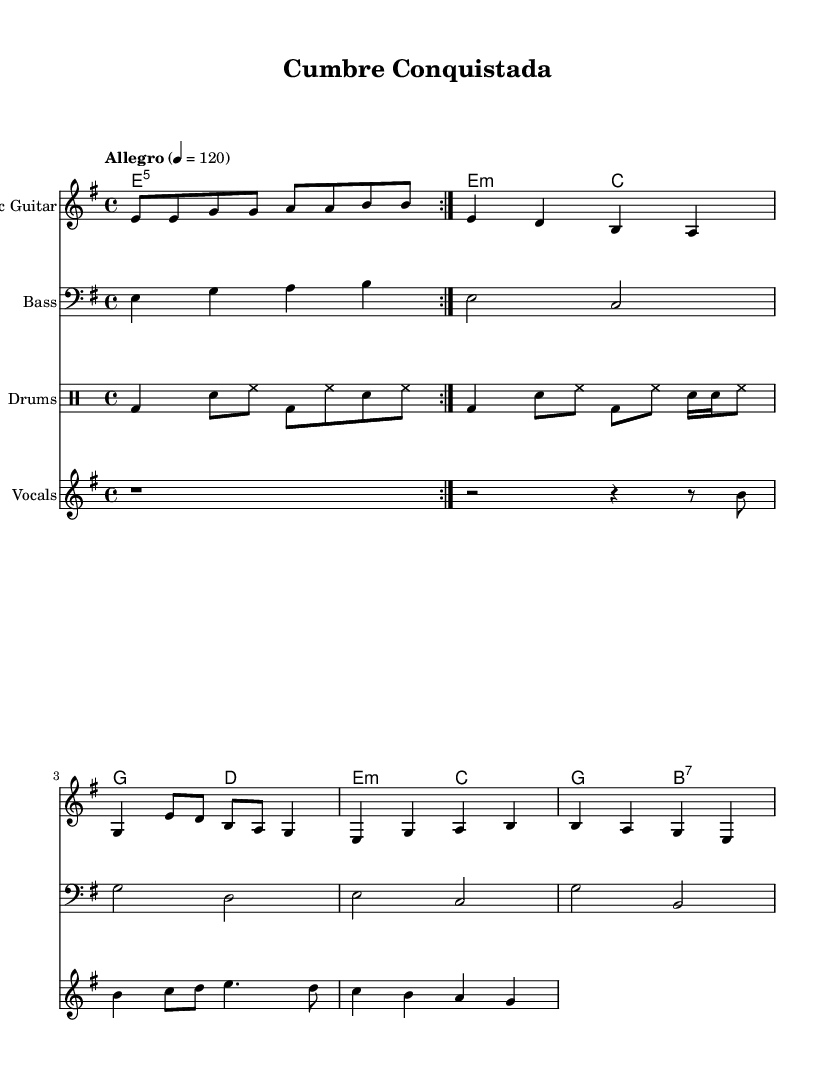What is the key signature of this music? The key signature is E minor, which has one sharp (F#). This is shown at the beginning of the score.
Answer: E minor What is the time signature of this music? The time signature is 4/4, indicated at the beginning of the score, which means there are four beats in a measure.
Answer: 4/4 What is the tempo marking of this piece? The tempo marking is "Allegro" with a metronome marking of 120. This indicates a fast tempo, providing energy to the piece.
Answer: Allegro, 120 How many measures are in the verse section? The verse section contains 4 measures, which can be counted visually from the musical notation between the intro and the chorus.
Answer: 4 Which instrument plays the introduction? The introduction is played by the Electric Guitar, as specified at the start of its staff.
Answer: Electric Guitar What is the primary rhythm style indicated in the drums? The primary rhythm style in the drums is a Latin rock beat, as indicated by the drum notation pattern outlined at the beginning of the drums part.
Answer: Latin rock beat How many beats does the first chorus last? The first chorus lasts a total of 12 beats, as the measures can be counted from the chorus section. Each measure is in 4/4, totaling to first 4 measures.
Answer: 12 